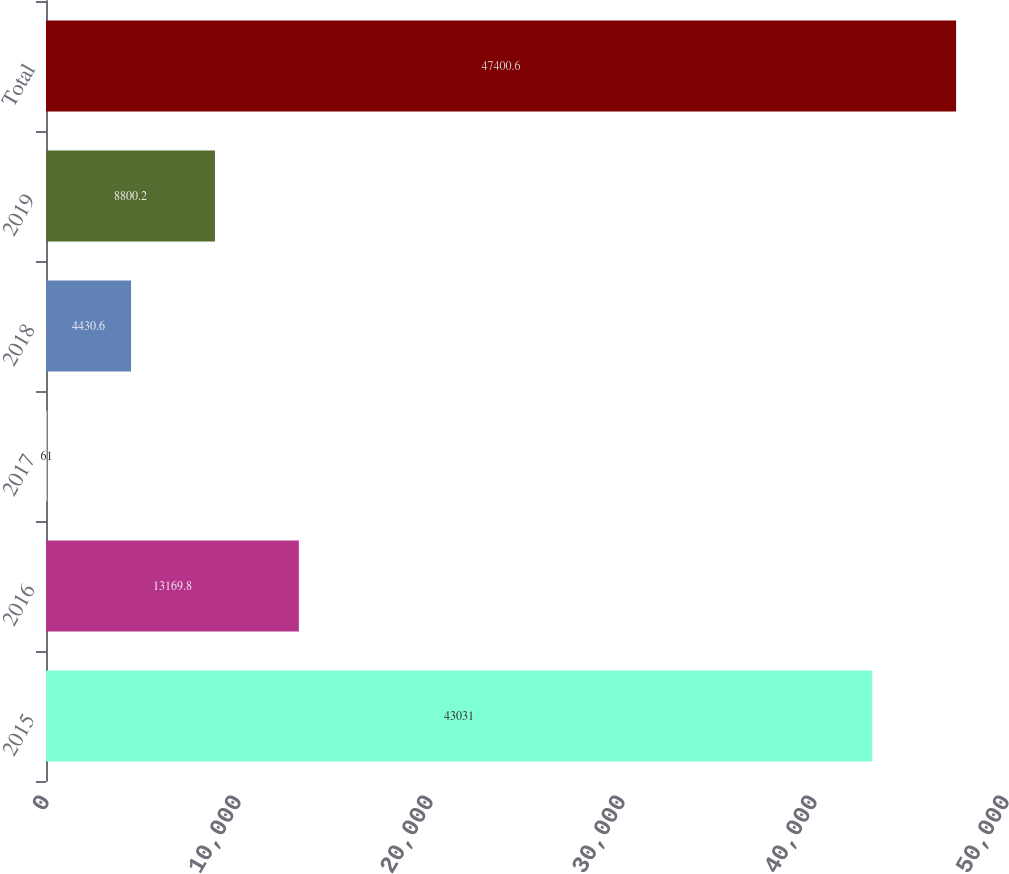Convert chart. <chart><loc_0><loc_0><loc_500><loc_500><bar_chart><fcel>2015<fcel>2016<fcel>2017<fcel>2018<fcel>2019<fcel>Total<nl><fcel>43031<fcel>13169.8<fcel>61<fcel>4430.6<fcel>8800.2<fcel>47400.6<nl></chart> 